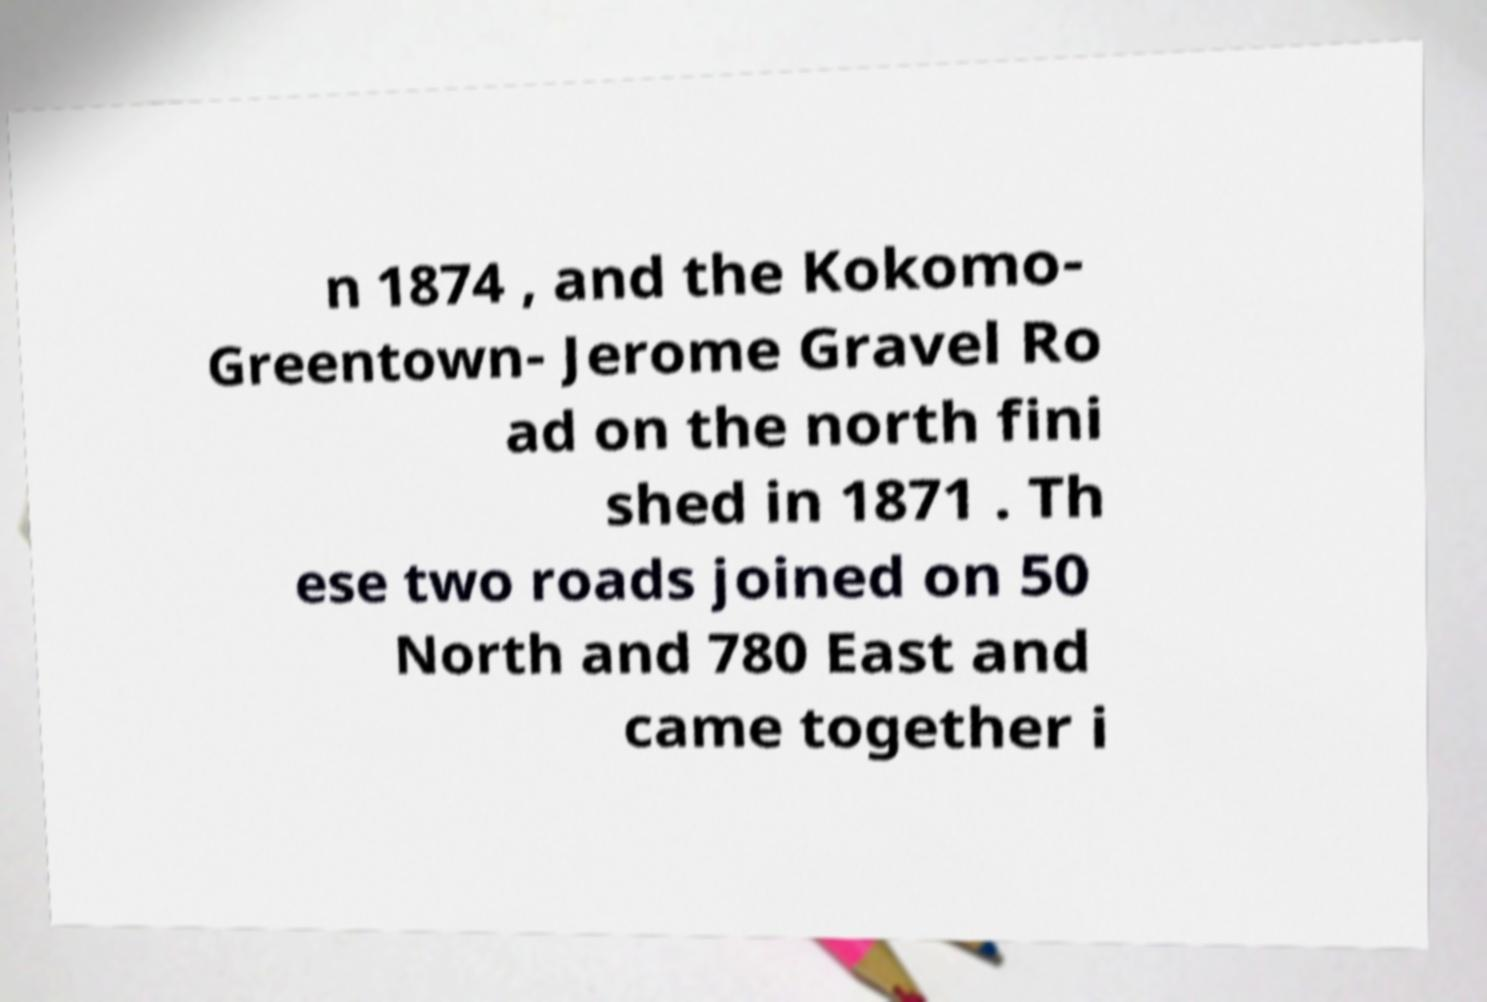For documentation purposes, I need the text within this image transcribed. Could you provide that? n 1874 , and the Kokomo- Greentown- Jerome Gravel Ro ad on the north fini shed in 1871 . Th ese two roads joined on 50 North and 780 East and came together i 